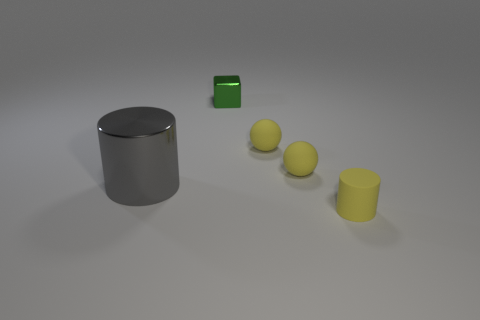Add 5 big objects. How many objects exist? 10 Subtract all blocks. How many objects are left? 4 Add 4 tiny green metal objects. How many tiny green metal objects are left? 5 Add 2 green objects. How many green objects exist? 3 Subtract 0 yellow blocks. How many objects are left? 5 Subtract all yellow cylinders. Subtract all small blue matte spheres. How many objects are left? 4 